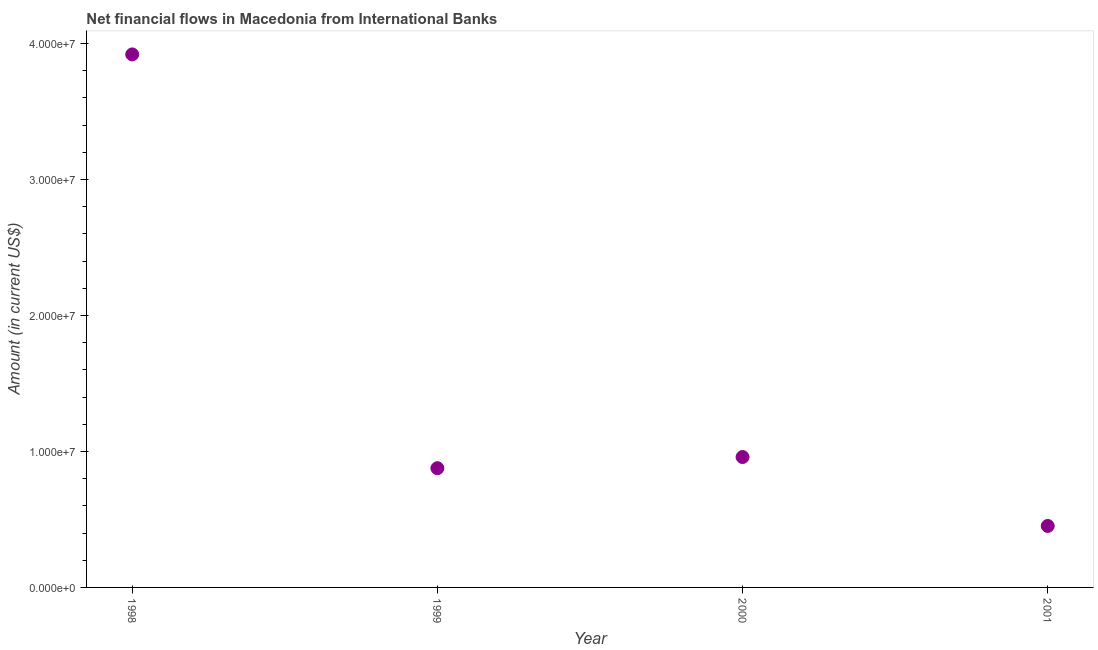What is the net financial flows from ibrd in 1999?
Make the answer very short. 8.77e+06. Across all years, what is the maximum net financial flows from ibrd?
Ensure brevity in your answer.  3.92e+07. Across all years, what is the minimum net financial flows from ibrd?
Your response must be concise. 4.52e+06. In which year was the net financial flows from ibrd minimum?
Your answer should be very brief. 2001. What is the sum of the net financial flows from ibrd?
Your answer should be very brief. 6.21e+07. What is the difference between the net financial flows from ibrd in 1999 and 2001?
Offer a terse response. 4.25e+06. What is the average net financial flows from ibrd per year?
Provide a short and direct response. 1.55e+07. What is the median net financial flows from ibrd?
Ensure brevity in your answer.  9.18e+06. What is the ratio of the net financial flows from ibrd in 1999 to that in 2001?
Ensure brevity in your answer.  1.94. What is the difference between the highest and the second highest net financial flows from ibrd?
Offer a very short reply. 2.96e+07. Is the sum of the net financial flows from ibrd in 2000 and 2001 greater than the maximum net financial flows from ibrd across all years?
Your answer should be compact. No. What is the difference between the highest and the lowest net financial flows from ibrd?
Your answer should be very brief. 3.47e+07. Are the values on the major ticks of Y-axis written in scientific E-notation?
Ensure brevity in your answer.  Yes. What is the title of the graph?
Your response must be concise. Net financial flows in Macedonia from International Banks. What is the Amount (in current US$) in 1998?
Your response must be concise. 3.92e+07. What is the Amount (in current US$) in 1999?
Make the answer very short. 8.77e+06. What is the Amount (in current US$) in 2000?
Your response must be concise. 9.59e+06. What is the Amount (in current US$) in 2001?
Provide a short and direct response. 4.52e+06. What is the difference between the Amount (in current US$) in 1998 and 1999?
Offer a terse response. 3.04e+07. What is the difference between the Amount (in current US$) in 1998 and 2000?
Make the answer very short. 2.96e+07. What is the difference between the Amount (in current US$) in 1998 and 2001?
Provide a succinct answer. 3.47e+07. What is the difference between the Amount (in current US$) in 1999 and 2000?
Offer a very short reply. -8.21e+05. What is the difference between the Amount (in current US$) in 1999 and 2001?
Your answer should be compact. 4.25e+06. What is the difference between the Amount (in current US$) in 2000 and 2001?
Provide a succinct answer. 5.07e+06. What is the ratio of the Amount (in current US$) in 1998 to that in 1999?
Your response must be concise. 4.47. What is the ratio of the Amount (in current US$) in 1998 to that in 2000?
Provide a succinct answer. 4.09. What is the ratio of the Amount (in current US$) in 1998 to that in 2001?
Your response must be concise. 8.67. What is the ratio of the Amount (in current US$) in 1999 to that in 2000?
Ensure brevity in your answer.  0.91. What is the ratio of the Amount (in current US$) in 1999 to that in 2001?
Offer a very short reply. 1.94. What is the ratio of the Amount (in current US$) in 2000 to that in 2001?
Give a very brief answer. 2.12. 